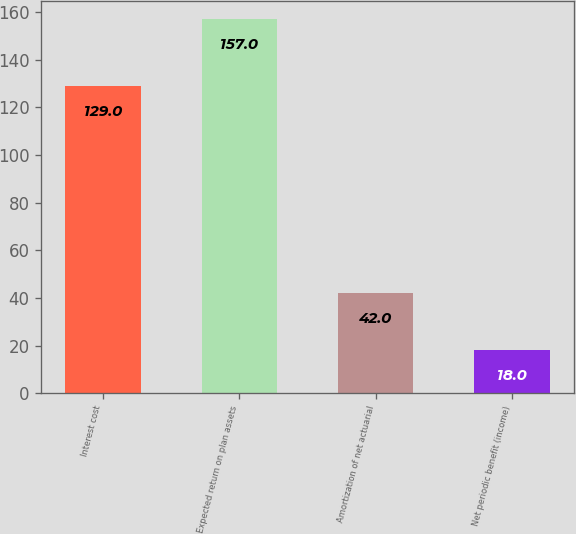Convert chart. <chart><loc_0><loc_0><loc_500><loc_500><bar_chart><fcel>Interest cost<fcel>Expected return on plan assets<fcel>Amortization of net actuarial<fcel>Net periodic benefit (income)<nl><fcel>129<fcel>157<fcel>42<fcel>18<nl></chart> 